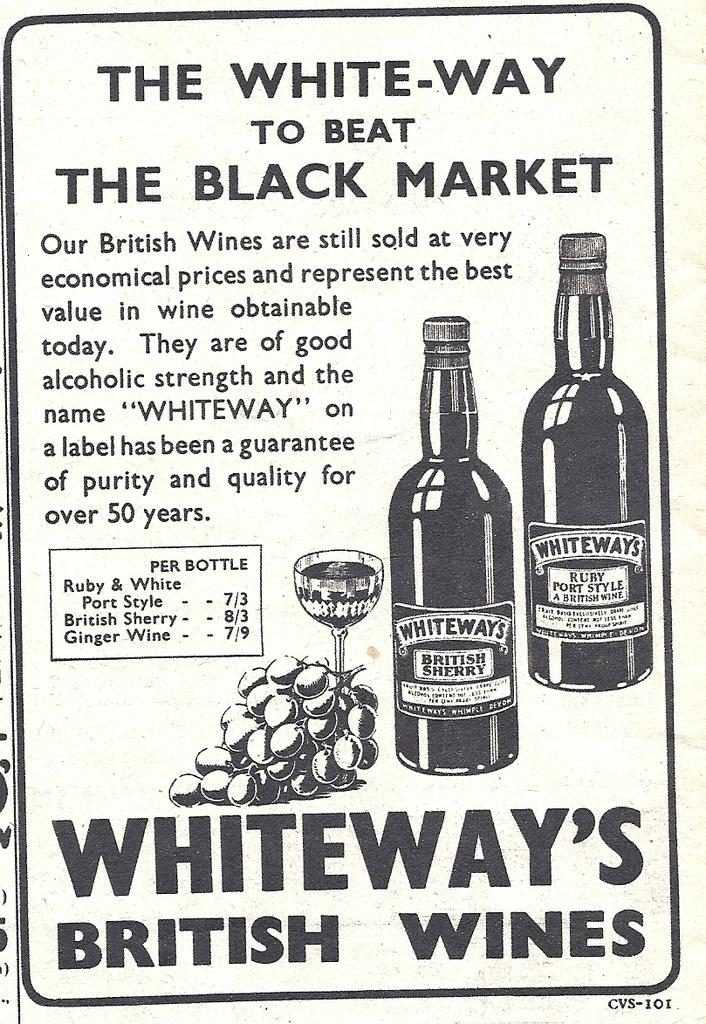<image>
Render a clear and concise summary of the photo. A poster in white and black advertising Whiteway's British Wines. 